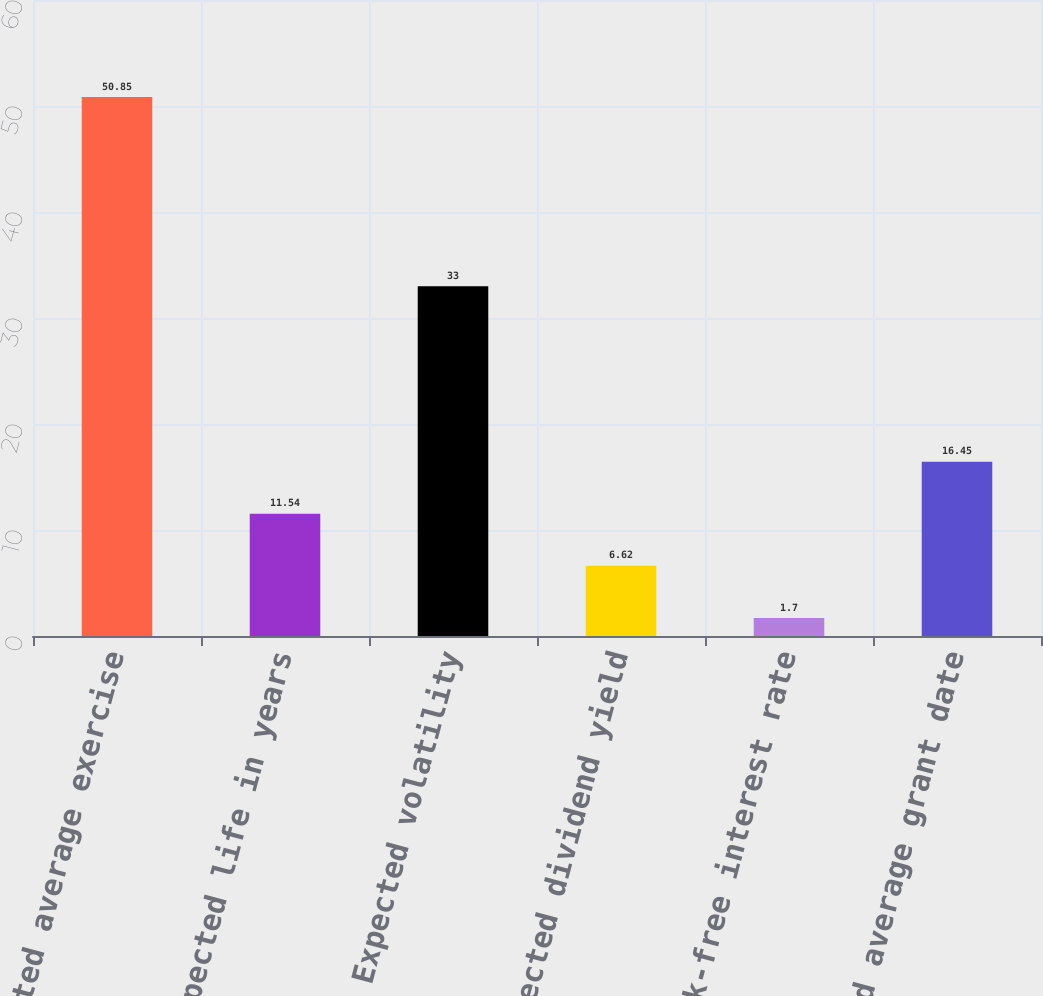<chart> <loc_0><loc_0><loc_500><loc_500><bar_chart><fcel>Weighted average exercise<fcel>Expected life in years<fcel>Expected volatility<fcel>Expected dividend yield<fcel>Risk-free interest rate<fcel>Weighted average grant date<nl><fcel>50.85<fcel>11.54<fcel>33<fcel>6.62<fcel>1.7<fcel>16.45<nl></chart> 